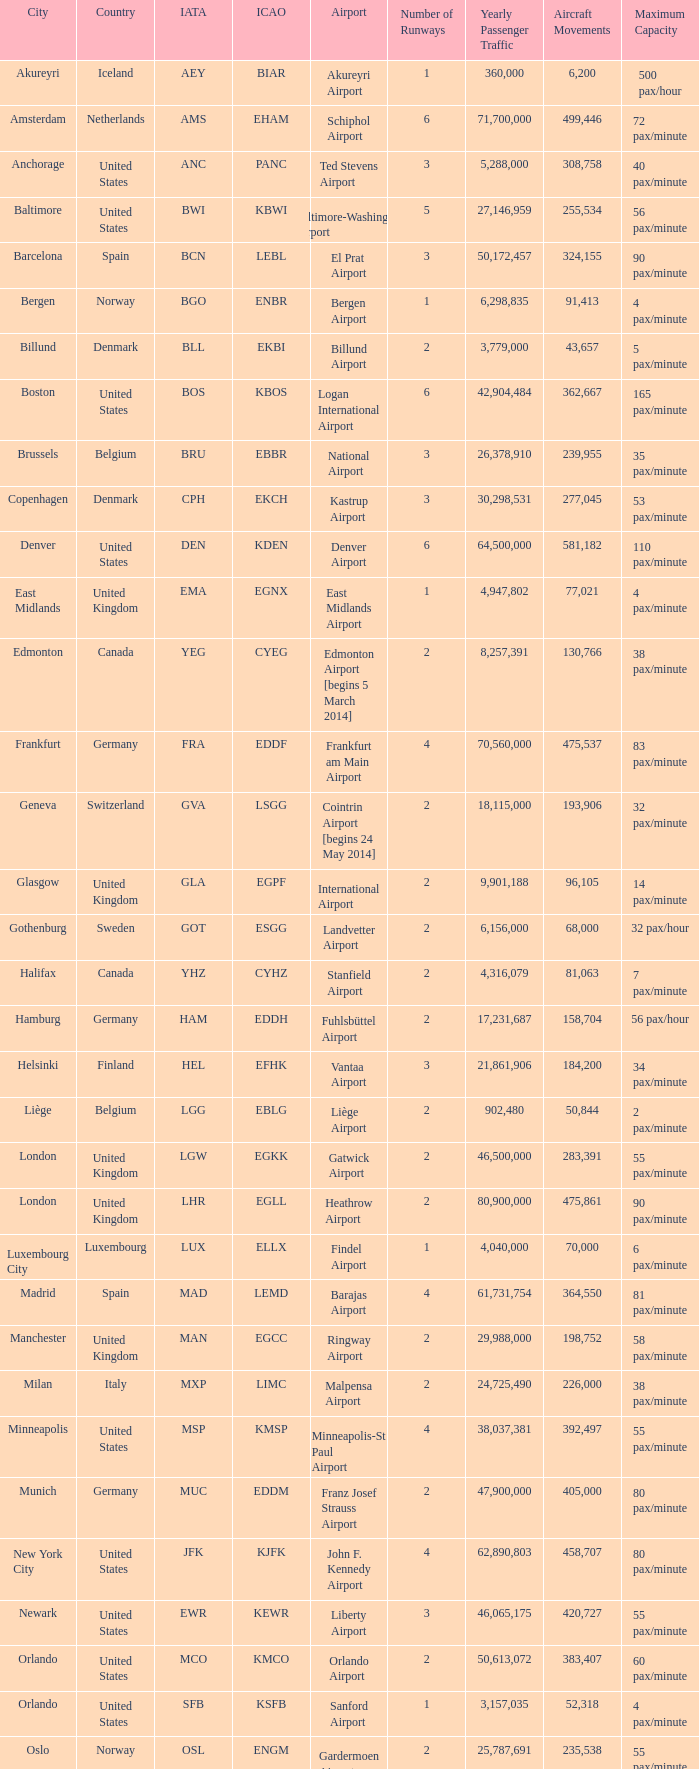What is the Airport with the ICAO fo KSEA? Seattle–Tacoma Airport. 